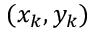<formula> <loc_0><loc_0><loc_500><loc_500>( x _ { k } , y _ { k } )</formula> 